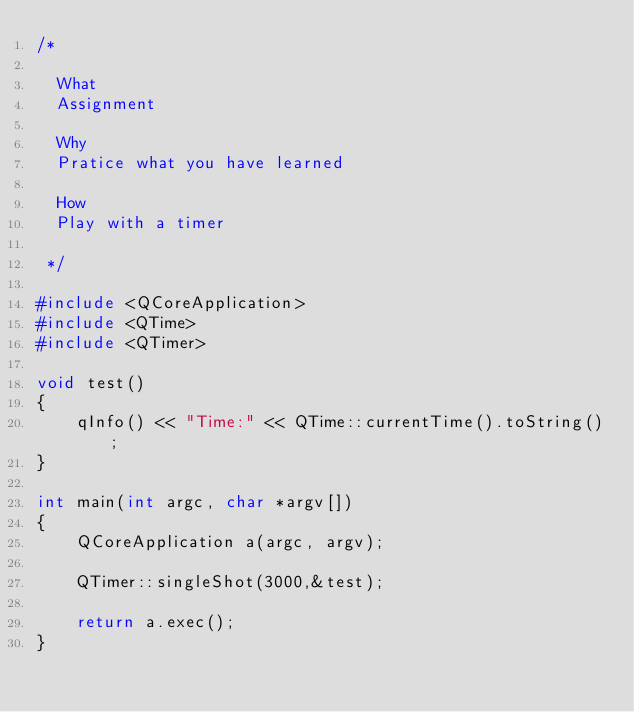Convert code to text. <code><loc_0><loc_0><loc_500><loc_500><_C++_>/*

  What
  Assignment

  Why
  Pratice what you have learned

  How
  Play with a timer

 */

#include <QCoreApplication>
#include <QTime>
#include <QTimer>

void test()
{
    qInfo() << "Time:" << QTime::currentTime().toString();
}

int main(int argc, char *argv[])
{
    QCoreApplication a(argc, argv);

    QTimer::singleShot(3000,&test);

    return a.exec();
}
</code> 